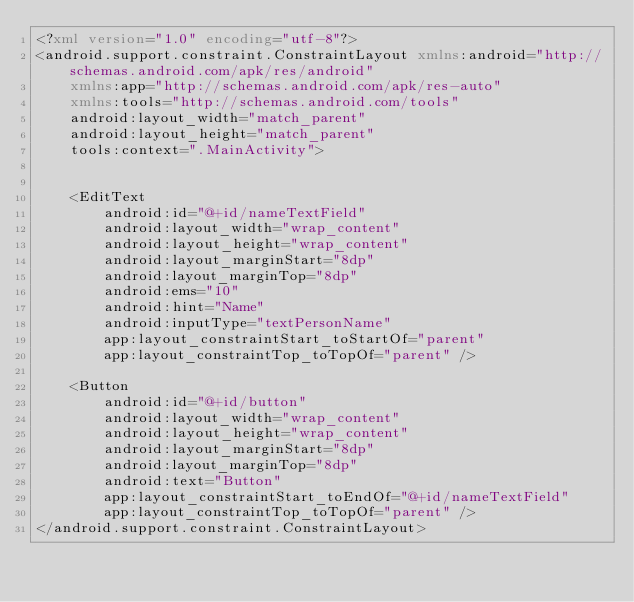<code> <loc_0><loc_0><loc_500><loc_500><_XML_><?xml version="1.0" encoding="utf-8"?>
<android.support.constraint.ConstraintLayout xmlns:android="http://schemas.android.com/apk/res/android"
    xmlns:app="http://schemas.android.com/apk/res-auto"
    xmlns:tools="http://schemas.android.com/tools"
    android:layout_width="match_parent"
    android:layout_height="match_parent"
    tools:context=".MainActivity">


    <EditText
        android:id="@+id/nameTextField"
        android:layout_width="wrap_content"
        android:layout_height="wrap_content"
        android:layout_marginStart="8dp"
        android:layout_marginTop="8dp"
        android:ems="10"
        android:hint="Name"
        android:inputType="textPersonName"
        app:layout_constraintStart_toStartOf="parent"
        app:layout_constraintTop_toTopOf="parent" />

    <Button
        android:id="@+id/button"
        android:layout_width="wrap_content"
        android:layout_height="wrap_content"
        android:layout_marginStart="8dp"
        android:layout_marginTop="8dp"
        android:text="Button"
        app:layout_constraintStart_toEndOf="@+id/nameTextField"
        app:layout_constraintTop_toTopOf="parent" />
</android.support.constraint.ConstraintLayout></code> 